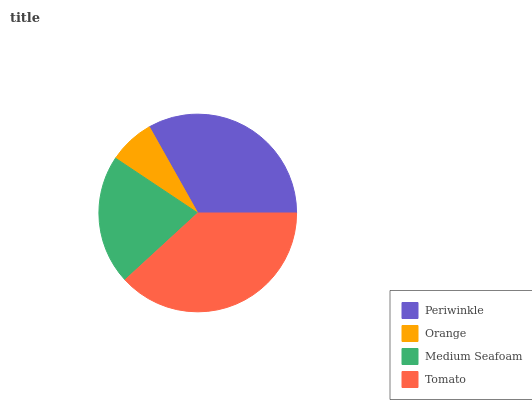Is Orange the minimum?
Answer yes or no. Yes. Is Tomato the maximum?
Answer yes or no. Yes. Is Medium Seafoam the minimum?
Answer yes or no. No. Is Medium Seafoam the maximum?
Answer yes or no. No. Is Medium Seafoam greater than Orange?
Answer yes or no. Yes. Is Orange less than Medium Seafoam?
Answer yes or no. Yes. Is Orange greater than Medium Seafoam?
Answer yes or no. No. Is Medium Seafoam less than Orange?
Answer yes or no. No. Is Periwinkle the high median?
Answer yes or no. Yes. Is Medium Seafoam the low median?
Answer yes or no. Yes. Is Tomato the high median?
Answer yes or no. No. Is Tomato the low median?
Answer yes or no. No. 